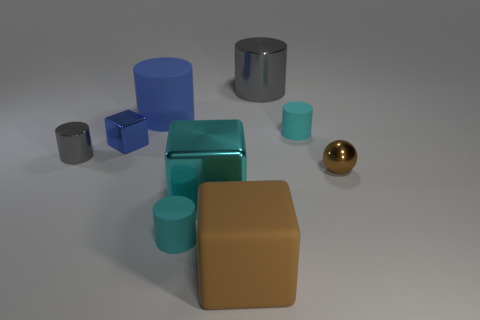Subtract all red blocks. How many cyan cylinders are left? 2 Subtract all gray shiny cylinders. How many cylinders are left? 3 Add 1 small purple metal objects. How many objects exist? 10 Subtract all gray cylinders. How many cylinders are left? 3 Subtract all blocks. How many objects are left? 6 Subtract 3 cylinders. How many cylinders are left? 2 Subtract 1 cyan cylinders. How many objects are left? 8 Subtract all green cylinders. Subtract all brown blocks. How many cylinders are left? 5 Subtract all brown matte objects. Subtract all brown spheres. How many objects are left? 7 Add 8 metal balls. How many metal balls are left? 9 